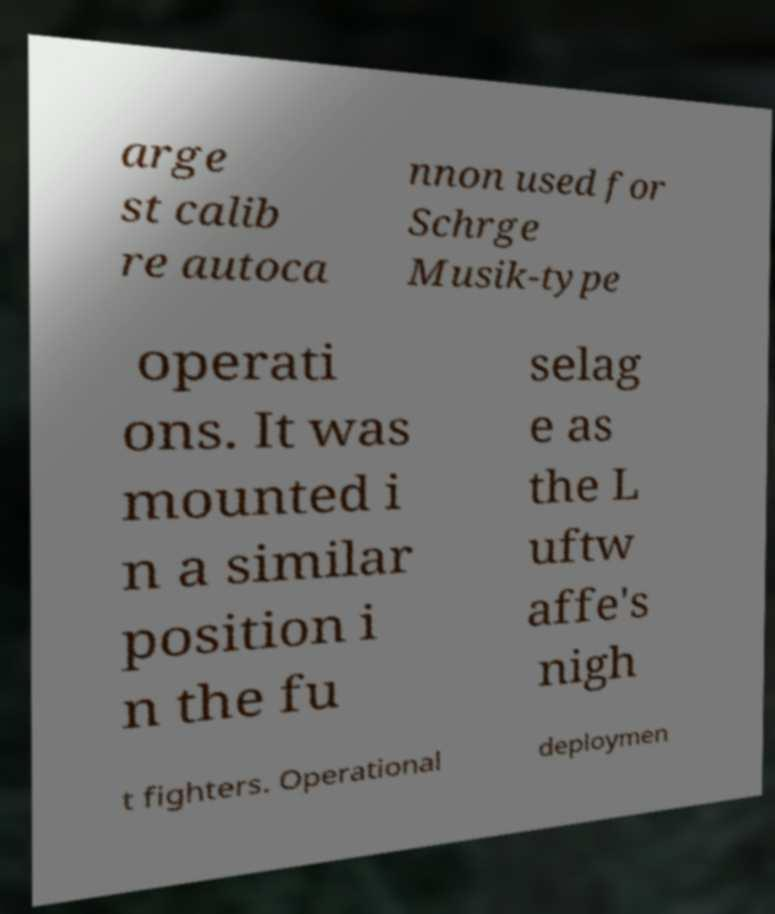For documentation purposes, I need the text within this image transcribed. Could you provide that? arge st calib re autoca nnon used for Schrge Musik-type operati ons. It was mounted i n a similar position i n the fu selag e as the L uftw affe's nigh t fighters. Operational deploymen 